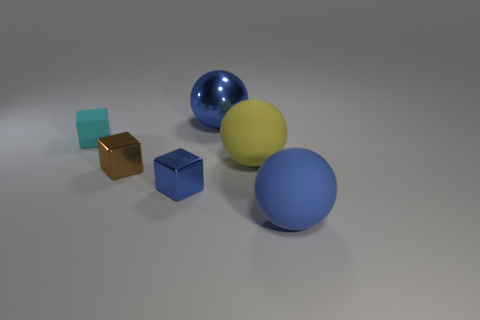Which object is closest to the camera? The blue matte sphere is the closest object to the camera, situated prominently in the foreground.  Can you describe the lighting in the scene? The lighting appears to be soft and diffused, coming from the upper left, casting gentle shadows to the right of the objects. 